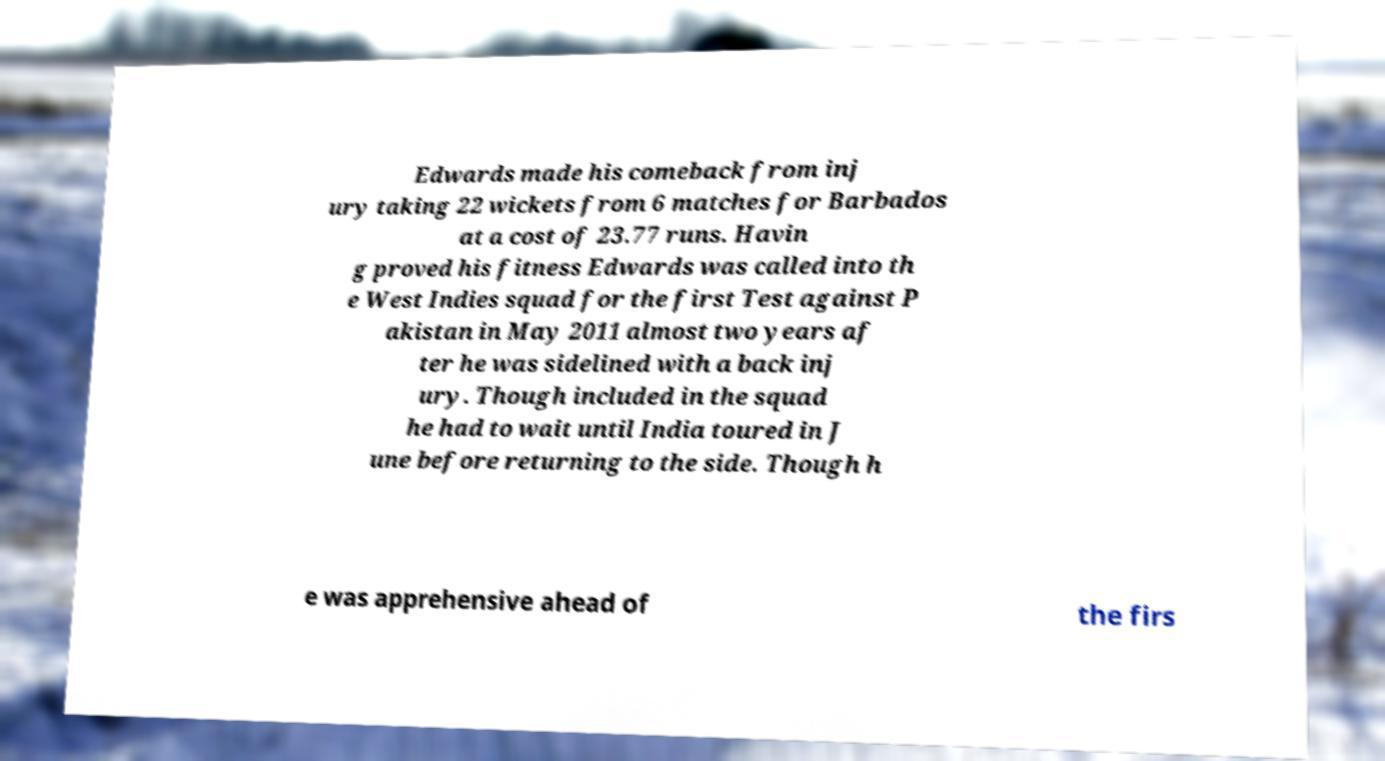Can you read and provide the text displayed in the image?This photo seems to have some interesting text. Can you extract and type it out for me? Edwards made his comeback from inj ury taking 22 wickets from 6 matches for Barbados at a cost of 23.77 runs. Havin g proved his fitness Edwards was called into th e West Indies squad for the first Test against P akistan in May 2011 almost two years af ter he was sidelined with a back inj ury. Though included in the squad he had to wait until India toured in J une before returning to the side. Though h e was apprehensive ahead of the firs 